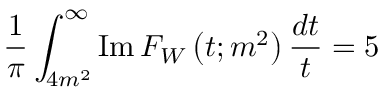Convert formula to latex. <formula><loc_0><loc_0><loc_500><loc_500>\frac { 1 } { \pi } \int _ { 4 m ^ { 2 } } ^ { \infty } I m \, F _ { W } \left ( t ; m ^ { 2 } \right ) \frac { d t } { t } = 5</formula> 